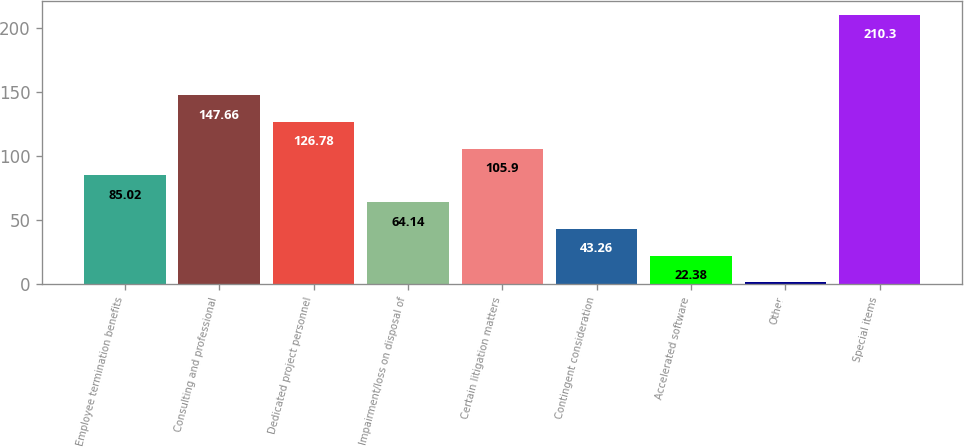<chart> <loc_0><loc_0><loc_500><loc_500><bar_chart><fcel>Employee termination benefits<fcel>Consulting and professional<fcel>Dedicated project personnel<fcel>Impairment/loss on disposal of<fcel>Certain litigation matters<fcel>Contingent consideration<fcel>Accelerated software<fcel>Other<fcel>Special items<nl><fcel>85.02<fcel>147.66<fcel>126.78<fcel>64.14<fcel>105.9<fcel>43.26<fcel>22.38<fcel>1.5<fcel>210.3<nl></chart> 